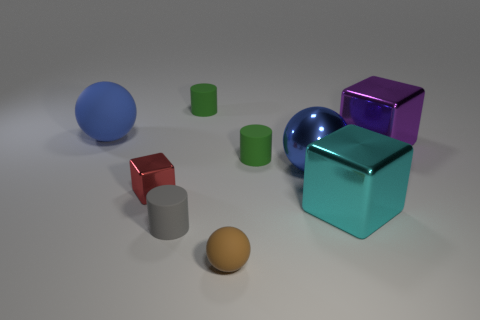Add 1 large metal balls. How many objects exist? 10 Subtract all cylinders. How many objects are left? 6 Add 5 tiny red cubes. How many tiny red cubes exist? 6 Subtract 0 red balls. How many objects are left? 9 Subtract all tiny purple balls. Subtract all large spheres. How many objects are left? 7 Add 1 metallic things. How many metallic things are left? 5 